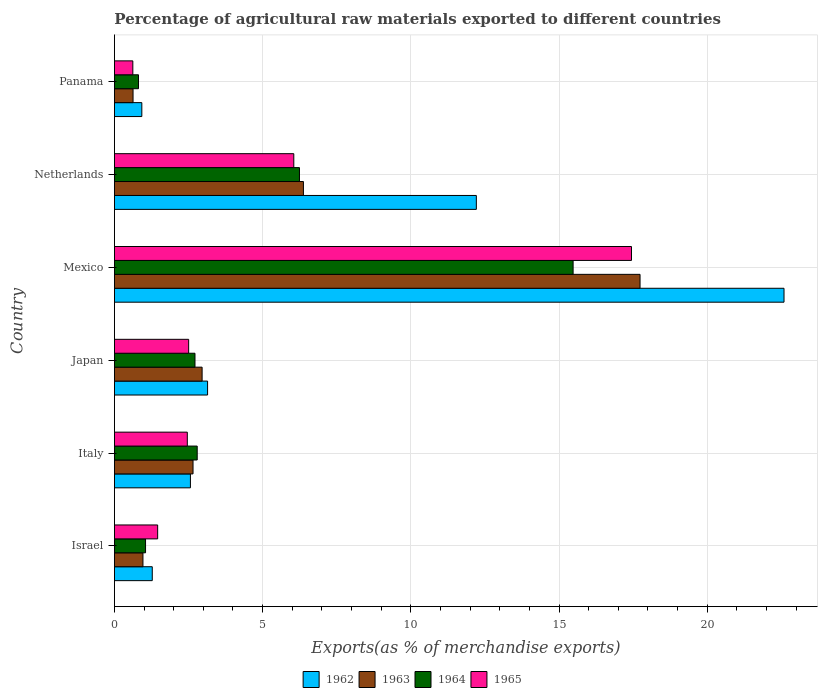How many different coloured bars are there?
Provide a short and direct response. 4. How many groups of bars are there?
Provide a succinct answer. 6. Are the number of bars per tick equal to the number of legend labels?
Keep it short and to the point. Yes. Are the number of bars on each tick of the Y-axis equal?
Provide a succinct answer. Yes. How many bars are there on the 4th tick from the bottom?
Offer a terse response. 4. What is the label of the 3rd group of bars from the top?
Your response must be concise. Mexico. What is the percentage of exports to different countries in 1965 in Israel?
Keep it short and to the point. 1.46. Across all countries, what is the maximum percentage of exports to different countries in 1962?
Provide a short and direct response. 22.59. Across all countries, what is the minimum percentage of exports to different countries in 1962?
Ensure brevity in your answer.  0.92. In which country was the percentage of exports to different countries in 1965 minimum?
Provide a succinct answer. Panama. What is the total percentage of exports to different countries in 1963 in the graph?
Your answer should be compact. 31.31. What is the difference between the percentage of exports to different countries in 1963 in Israel and that in Italy?
Provide a short and direct response. -1.69. What is the difference between the percentage of exports to different countries in 1963 in Israel and the percentage of exports to different countries in 1962 in Panama?
Provide a succinct answer. 0.04. What is the average percentage of exports to different countries in 1963 per country?
Provide a short and direct response. 5.22. What is the difference between the percentage of exports to different countries in 1963 and percentage of exports to different countries in 1965 in Japan?
Give a very brief answer. 0.45. What is the ratio of the percentage of exports to different countries in 1962 in Mexico to that in Netherlands?
Offer a very short reply. 1.85. Is the difference between the percentage of exports to different countries in 1963 in Israel and Panama greater than the difference between the percentage of exports to different countries in 1965 in Israel and Panama?
Ensure brevity in your answer.  No. What is the difference between the highest and the second highest percentage of exports to different countries in 1962?
Your answer should be compact. 10.38. What is the difference between the highest and the lowest percentage of exports to different countries in 1962?
Offer a very short reply. 21.67. In how many countries, is the percentage of exports to different countries in 1964 greater than the average percentage of exports to different countries in 1964 taken over all countries?
Your answer should be compact. 2. Is it the case that in every country, the sum of the percentage of exports to different countries in 1965 and percentage of exports to different countries in 1963 is greater than the sum of percentage of exports to different countries in 1962 and percentage of exports to different countries in 1964?
Provide a short and direct response. No. What does the 3rd bar from the bottom in Panama represents?
Provide a short and direct response. 1964. Is it the case that in every country, the sum of the percentage of exports to different countries in 1962 and percentage of exports to different countries in 1963 is greater than the percentage of exports to different countries in 1964?
Provide a succinct answer. Yes. How many bars are there?
Ensure brevity in your answer.  24. Are the values on the major ticks of X-axis written in scientific E-notation?
Give a very brief answer. No. Does the graph contain grids?
Give a very brief answer. Yes. Where does the legend appear in the graph?
Provide a succinct answer. Bottom center. How are the legend labels stacked?
Offer a terse response. Horizontal. What is the title of the graph?
Offer a terse response. Percentage of agricultural raw materials exported to different countries. Does "1993" appear as one of the legend labels in the graph?
Your answer should be compact. No. What is the label or title of the X-axis?
Provide a succinct answer. Exports(as % of merchandise exports). What is the label or title of the Y-axis?
Make the answer very short. Country. What is the Exports(as % of merchandise exports) in 1962 in Israel?
Keep it short and to the point. 1.28. What is the Exports(as % of merchandise exports) in 1963 in Israel?
Your answer should be very brief. 0.96. What is the Exports(as % of merchandise exports) in 1964 in Israel?
Keep it short and to the point. 1.05. What is the Exports(as % of merchandise exports) of 1965 in Israel?
Keep it short and to the point. 1.46. What is the Exports(as % of merchandise exports) in 1962 in Italy?
Make the answer very short. 2.56. What is the Exports(as % of merchandise exports) in 1963 in Italy?
Your response must be concise. 2.65. What is the Exports(as % of merchandise exports) in 1964 in Italy?
Offer a terse response. 2.79. What is the Exports(as % of merchandise exports) in 1965 in Italy?
Provide a succinct answer. 2.46. What is the Exports(as % of merchandise exports) in 1962 in Japan?
Your answer should be compact. 3.14. What is the Exports(as % of merchandise exports) in 1963 in Japan?
Make the answer very short. 2.96. What is the Exports(as % of merchandise exports) of 1964 in Japan?
Provide a succinct answer. 2.72. What is the Exports(as % of merchandise exports) in 1965 in Japan?
Offer a terse response. 2.5. What is the Exports(as % of merchandise exports) in 1962 in Mexico?
Give a very brief answer. 22.59. What is the Exports(as % of merchandise exports) of 1963 in Mexico?
Your response must be concise. 17.73. What is the Exports(as % of merchandise exports) in 1964 in Mexico?
Provide a short and direct response. 15.48. What is the Exports(as % of merchandise exports) of 1965 in Mexico?
Provide a short and direct response. 17.44. What is the Exports(as % of merchandise exports) of 1962 in Netherlands?
Provide a short and direct response. 12.21. What is the Exports(as % of merchandise exports) of 1963 in Netherlands?
Give a very brief answer. 6.38. What is the Exports(as % of merchandise exports) of 1964 in Netherlands?
Make the answer very short. 6.24. What is the Exports(as % of merchandise exports) of 1965 in Netherlands?
Provide a short and direct response. 6.05. What is the Exports(as % of merchandise exports) of 1962 in Panama?
Your answer should be compact. 0.92. What is the Exports(as % of merchandise exports) of 1963 in Panama?
Make the answer very short. 0.63. What is the Exports(as % of merchandise exports) in 1964 in Panama?
Give a very brief answer. 0.81. What is the Exports(as % of merchandise exports) in 1965 in Panama?
Provide a succinct answer. 0.62. Across all countries, what is the maximum Exports(as % of merchandise exports) of 1962?
Make the answer very short. 22.59. Across all countries, what is the maximum Exports(as % of merchandise exports) of 1963?
Your answer should be very brief. 17.73. Across all countries, what is the maximum Exports(as % of merchandise exports) in 1964?
Provide a short and direct response. 15.48. Across all countries, what is the maximum Exports(as % of merchandise exports) in 1965?
Ensure brevity in your answer.  17.44. Across all countries, what is the minimum Exports(as % of merchandise exports) in 1962?
Offer a terse response. 0.92. Across all countries, what is the minimum Exports(as % of merchandise exports) of 1963?
Offer a very short reply. 0.63. Across all countries, what is the minimum Exports(as % of merchandise exports) in 1964?
Make the answer very short. 0.81. Across all countries, what is the minimum Exports(as % of merchandise exports) of 1965?
Your answer should be very brief. 0.62. What is the total Exports(as % of merchandise exports) in 1962 in the graph?
Give a very brief answer. 42.71. What is the total Exports(as % of merchandise exports) of 1963 in the graph?
Provide a succinct answer. 31.31. What is the total Exports(as % of merchandise exports) in 1964 in the graph?
Offer a very short reply. 29.09. What is the total Exports(as % of merchandise exports) of 1965 in the graph?
Your answer should be compact. 30.54. What is the difference between the Exports(as % of merchandise exports) in 1962 in Israel and that in Italy?
Provide a short and direct response. -1.29. What is the difference between the Exports(as % of merchandise exports) of 1963 in Israel and that in Italy?
Provide a short and direct response. -1.69. What is the difference between the Exports(as % of merchandise exports) in 1964 in Israel and that in Italy?
Provide a succinct answer. -1.74. What is the difference between the Exports(as % of merchandise exports) in 1965 in Israel and that in Italy?
Provide a succinct answer. -1. What is the difference between the Exports(as % of merchandise exports) of 1962 in Israel and that in Japan?
Make the answer very short. -1.87. What is the difference between the Exports(as % of merchandise exports) in 1963 in Israel and that in Japan?
Keep it short and to the point. -2. What is the difference between the Exports(as % of merchandise exports) in 1964 in Israel and that in Japan?
Ensure brevity in your answer.  -1.67. What is the difference between the Exports(as % of merchandise exports) in 1965 in Israel and that in Japan?
Keep it short and to the point. -1.05. What is the difference between the Exports(as % of merchandise exports) of 1962 in Israel and that in Mexico?
Your response must be concise. -21.31. What is the difference between the Exports(as % of merchandise exports) in 1963 in Israel and that in Mexico?
Keep it short and to the point. -16.77. What is the difference between the Exports(as % of merchandise exports) of 1964 in Israel and that in Mexico?
Provide a short and direct response. -14.43. What is the difference between the Exports(as % of merchandise exports) of 1965 in Israel and that in Mexico?
Ensure brevity in your answer.  -15.99. What is the difference between the Exports(as % of merchandise exports) in 1962 in Israel and that in Netherlands?
Offer a very short reply. -10.93. What is the difference between the Exports(as % of merchandise exports) in 1963 in Israel and that in Netherlands?
Your answer should be compact. -5.41. What is the difference between the Exports(as % of merchandise exports) of 1964 in Israel and that in Netherlands?
Provide a succinct answer. -5.19. What is the difference between the Exports(as % of merchandise exports) of 1965 in Israel and that in Netherlands?
Provide a succinct answer. -4.59. What is the difference between the Exports(as % of merchandise exports) of 1962 in Israel and that in Panama?
Your answer should be very brief. 0.35. What is the difference between the Exports(as % of merchandise exports) of 1963 in Israel and that in Panama?
Give a very brief answer. 0.33. What is the difference between the Exports(as % of merchandise exports) in 1964 in Israel and that in Panama?
Offer a terse response. 0.24. What is the difference between the Exports(as % of merchandise exports) of 1965 in Israel and that in Panama?
Your response must be concise. 0.84. What is the difference between the Exports(as % of merchandise exports) in 1962 in Italy and that in Japan?
Your answer should be very brief. -0.58. What is the difference between the Exports(as % of merchandise exports) of 1963 in Italy and that in Japan?
Keep it short and to the point. -0.31. What is the difference between the Exports(as % of merchandise exports) of 1964 in Italy and that in Japan?
Keep it short and to the point. 0.07. What is the difference between the Exports(as % of merchandise exports) in 1965 in Italy and that in Japan?
Provide a succinct answer. -0.05. What is the difference between the Exports(as % of merchandise exports) in 1962 in Italy and that in Mexico?
Give a very brief answer. -20.03. What is the difference between the Exports(as % of merchandise exports) in 1963 in Italy and that in Mexico?
Ensure brevity in your answer.  -15.08. What is the difference between the Exports(as % of merchandise exports) of 1964 in Italy and that in Mexico?
Keep it short and to the point. -12.68. What is the difference between the Exports(as % of merchandise exports) of 1965 in Italy and that in Mexico?
Offer a very short reply. -14.99. What is the difference between the Exports(as % of merchandise exports) in 1962 in Italy and that in Netherlands?
Make the answer very short. -9.65. What is the difference between the Exports(as % of merchandise exports) of 1963 in Italy and that in Netherlands?
Make the answer very short. -3.72. What is the difference between the Exports(as % of merchandise exports) of 1964 in Italy and that in Netherlands?
Provide a succinct answer. -3.45. What is the difference between the Exports(as % of merchandise exports) of 1965 in Italy and that in Netherlands?
Provide a short and direct response. -3.59. What is the difference between the Exports(as % of merchandise exports) in 1962 in Italy and that in Panama?
Give a very brief answer. 1.64. What is the difference between the Exports(as % of merchandise exports) of 1963 in Italy and that in Panama?
Your answer should be very brief. 2.02. What is the difference between the Exports(as % of merchandise exports) in 1964 in Italy and that in Panama?
Give a very brief answer. 1.98. What is the difference between the Exports(as % of merchandise exports) in 1965 in Italy and that in Panama?
Give a very brief answer. 1.84. What is the difference between the Exports(as % of merchandise exports) of 1962 in Japan and that in Mexico?
Your answer should be compact. -19.45. What is the difference between the Exports(as % of merchandise exports) in 1963 in Japan and that in Mexico?
Your response must be concise. -14.78. What is the difference between the Exports(as % of merchandise exports) of 1964 in Japan and that in Mexico?
Offer a very short reply. -12.76. What is the difference between the Exports(as % of merchandise exports) in 1965 in Japan and that in Mexico?
Your response must be concise. -14.94. What is the difference between the Exports(as % of merchandise exports) in 1962 in Japan and that in Netherlands?
Give a very brief answer. -9.07. What is the difference between the Exports(as % of merchandise exports) of 1963 in Japan and that in Netherlands?
Provide a short and direct response. -3.42. What is the difference between the Exports(as % of merchandise exports) in 1964 in Japan and that in Netherlands?
Keep it short and to the point. -3.53. What is the difference between the Exports(as % of merchandise exports) in 1965 in Japan and that in Netherlands?
Provide a succinct answer. -3.55. What is the difference between the Exports(as % of merchandise exports) of 1962 in Japan and that in Panama?
Ensure brevity in your answer.  2.22. What is the difference between the Exports(as % of merchandise exports) in 1963 in Japan and that in Panama?
Provide a succinct answer. 2.33. What is the difference between the Exports(as % of merchandise exports) in 1964 in Japan and that in Panama?
Offer a terse response. 1.91. What is the difference between the Exports(as % of merchandise exports) in 1965 in Japan and that in Panama?
Offer a very short reply. 1.88. What is the difference between the Exports(as % of merchandise exports) of 1962 in Mexico and that in Netherlands?
Make the answer very short. 10.38. What is the difference between the Exports(as % of merchandise exports) of 1963 in Mexico and that in Netherlands?
Your answer should be very brief. 11.36. What is the difference between the Exports(as % of merchandise exports) in 1964 in Mexico and that in Netherlands?
Your answer should be compact. 9.23. What is the difference between the Exports(as % of merchandise exports) in 1965 in Mexico and that in Netherlands?
Keep it short and to the point. 11.39. What is the difference between the Exports(as % of merchandise exports) in 1962 in Mexico and that in Panama?
Your answer should be compact. 21.67. What is the difference between the Exports(as % of merchandise exports) in 1963 in Mexico and that in Panama?
Keep it short and to the point. 17.11. What is the difference between the Exports(as % of merchandise exports) in 1964 in Mexico and that in Panama?
Provide a short and direct response. 14.66. What is the difference between the Exports(as % of merchandise exports) in 1965 in Mexico and that in Panama?
Your answer should be compact. 16.82. What is the difference between the Exports(as % of merchandise exports) in 1962 in Netherlands and that in Panama?
Your answer should be very brief. 11.29. What is the difference between the Exports(as % of merchandise exports) in 1963 in Netherlands and that in Panama?
Offer a very short reply. 5.75. What is the difference between the Exports(as % of merchandise exports) of 1964 in Netherlands and that in Panama?
Keep it short and to the point. 5.43. What is the difference between the Exports(as % of merchandise exports) in 1965 in Netherlands and that in Panama?
Your response must be concise. 5.43. What is the difference between the Exports(as % of merchandise exports) of 1962 in Israel and the Exports(as % of merchandise exports) of 1963 in Italy?
Your answer should be very brief. -1.38. What is the difference between the Exports(as % of merchandise exports) of 1962 in Israel and the Exports(as % of merchandise exports) of 1964 in Italy?
Offer a very short reply. -1.52. What is the difference between the Exports(as % of merchandise exports) of 1962 in Israel and the Exports(as % of merchandise exports) of 1965 in Italy?
Ensure brevity in your answer.  -1.18. What is the difference between the Exports(as % of merchandise exports) in 1963 in Israel and the Exports(as % of merchandise exports) in 1964 in Italy?
Offer a very short reply. -1.83. What is the difference between the Exports(as % of merchandise exports) in 1963 in Israel and the Exports(as % of merchandise exports) in 1965 in Italy?
Offer a terse response. -1.5. What is the difference between the Exports(as % of merchandise exports) of 1964 in Israel and the Exports(as % of merchandise exports) of 1965 in Italy?
Offer a very short reply. -1.41. What is the difference between the Exports(as % of merchandise exports) of 1962 in Israel and the Exports(as % of merchandise exports) of 1963 in Japan?
Your answer should be compact. -1.68. What is the difference between the Exports(as % of merchandise exports) in 1962 in Israel and the Exports(as % of merchandise exports) in 1964 in Japan?
Offer a terse response. -1.44. What is the difference between the Exports(as % of merchandise exports) of 1962 in Israel and the Exports(as % of merchandise exports) of 1965 in Japan?
Make the answer very short. -1.23. What is the difference between the Exports(as % of merchandise exports) of 1963 in Israel and the Exports(as % of merchandise exports) of 1964 in Japan?
Your answer should be very brief. -1.76. What is the difference between the Exports(as % of merchandise exports) of 1963 in Israel and the Exports(as % of merchandise exports) of 1965 in Japan?
Make the answer very short. -1.54. What is the difference between the Exports(as % of merchandise exports) in 1964 in Israel and the Exports(as % of merchandise exports) in 1965 in Japan?
Offer a terse response. -1.45. What is the difference between the Exports(as % of merchandise exports) of 1962 in Israel and the Exports(as % of merchandise exports) of 1963 in Mexico?
Your response must be concise. -16.46. What is the difference between the Exports(as % of merchandise exports) of 1962 in Israel and the Exports(as % of merchandise exports) of 1964 in Mexico?
Keep it short and to the point. -14.2. What is the difference between the Exports(as % of merchandise exports) of 1962 in Israel and the Exports(as % of merchandise exports) of 1965 in Mexico?
Your response must be concise. -16.17. What is the difference between the Exports(as % of merchandise exports) of 1963 in Israel and the Exports(as % of merchandise exports) of 1964 in Mexico?
Ensure brevity in your answer.  -14.51. What is the difference between the Exports(as % of merchandise exports) in 1963 in Israel and the Exports(as % of merchandise exports) in 1965 in Mexico?
Your response must be concise. -16.48. What is the difference between the Exports(as % of merchandise exports) of 1964 in Israel and the Exports(as % of merchandise exports) of 1965 in Mexico?
Your response must be concise. -16.39. What is the difference between the Exports(as % of merchandise exports) of 1962 in Israel and the Exports(as % of merchandise exports) of 1963 in Netherlands?
Your answer should be very brief. -5.1. What is the difference between the Exports(as % of merchandise exports) of 1962 in Israel and the Exports(as % of merchandise exports) of 1964 in Netherlands?
Make the answer very short. -4.97. What is the difference between the Exports(as % of merchandise exports) in 1962 in Israel and the Exports(as % of merchandise exports) in 1965 in Netherlands?
Keep it short and to the point. -4.77. What is the difference between the Exports(as % of merchandise exports) of 1963 in Israel and the Exports(as % of merchandise exports) of 1964 in Netherlands?
Provide a succinct answer. -5.28. What is the difference between the Exports(as % of merchandise exports) in 1963 in Israel and the Exports(as % of merchandise exports) in 1965 in Netherlands?
Offer a terse response. -5.09. What is the difference between the Exports(as % of merchandise exports) in 1964 in Israel and the Exports(as % of merchandise exports) in 1965 in Netherlands?
Provide a short and direct response. -5. What is the difference between the Exports(as % of merchandise exports) of 1962 in Israel and the Exports(as % of merchandise exports) of 1963 in Panama?
Make the answer very short. 0.65. What is the difference between the Exports(as % of merchandise exports) of 1962 in Israel and the Exports(as % of merchandise exports) of 1964 in Panama?
Your response must be concise. 0.46. What is the difference between the Exports(as % of merchandise exports) in 1962 in Israel and the Exports(as % of merchandise exports) in 1965 in Panama?
Your answer should be very brief. 0.66. What is the difference between the Exports(as % of merchandise exports) in 1963 in Israel and the Exports(as % of merchandise exports) in 1964 in Panama?
Your response must be concise. 0.15. What is the difference between the Exports(as % of merchandise exports) in 1963 in Israel and the Exports(as % of merchandise exports) in 1965 in Panama?
Ensure brevity in your answer.  0.34. What is the difference between the Exports(as % of merchandise exports) in 1964 in Israel and the Exports(as % of merchandise exports) in 1965 in Panama?
Provide a short and direct response. 0.43. What is the difference between the Exports(as % of merchandise exports) in 1962 in Italy and the Exports(as % of merchandise exports) in 1963 in Japan?
Make the answer very short. -0.39. What is the difference between the Exports(as % of merchandise exports) in 1962 in Italy and the Exports(as % of merchandise exports) in 1964 in Japan?
Give a very brief answer. -0.15. What is the difference between the Exports(as % of merchandise exports) of 1962 in Italy and the Exports(as % of merchandise exports) of 1965 in Japan?
Your answer should be very brief. 0.06. What is the difference between the Exports(as % of merchandise exports) in 1963 in Italy and the Exports(as % of merchandise exports) in 1964 in Japan?
Ensure brevity in your answer.  -0.07. What is the difference between the Exports(as % of merchandise exports) of 1963 in Italy and the Exports(as % of merchandise exports) of 1965 in Japan?
Offer a terse response. 0.15. What is the difference between the Exports(as % of merchandise exports) of 1964 in Italy and the Exports(as % of merchandise exports) of 1965 in Japan?
Make the answer very short. 0.29. What is the difference between the Exports(as % of merchandise exports) of 1962 in Italy and the Exports(as % of merchandise exports) of 1963 in Mexico?
Provide a succinct answer. -15.17. What is the difference between the Exports(as % of merchandise exports) in 1962 in Italy and the Exports(as % of merchandise exports) in 1964 in Mexico?
Make the answer very short. -12.91. What is the difference between the Exports(as % of merchandise exports) in 1962 in Italy and the Exports(as % of merchandise exports) in 1965 in Mexico?
Provide a succinct answer. -14.88. What is the difference between the Exports(as % of merchandise exports) in 1963 in Italy and the Exports(as % of merchandise exports) in 1964 in Mexico?
Offer a terse response. -12.82. What is the difference between the Exports(as % of merchandise exports) in 1963 in Italy and the Exports(as % of merchandise exports) in 1965 in Mexico?
Offer a very short reply. -14.79. What is the difference between the Exports(as % of merchandise exports) in 1964 in Italy and the Exports(as % of merchandise exports) in 1965 in Mexico?
Keep it short and to the point. -14.65. What is the difference between the Exports(as % of merchandise exports) in 1962 in Italy and the Exports(as % of merchandise exports) in 1963 in Netherlands?
Your answer should be compact. -3.81. What is the difference between the Exports(as % of merchandise exports) in 1962 in Italy and the Exports(as % of merchandise exports) in 1964 in Netherlands?
Offer a very short reply. -3.68. What is the difference between the Exports(as % of merchandise exports) of 1962 in Italy and the Exports(as % of merchandise exports) of 1965 in Netherlands?
Your answer should be compact. -3.49. What is the difference between the Exports(as % of merchandise exports) of 1963 in Italy and the Exports(as % of merchandise exports) of 1964 in Netherlands?
Make the answer very short. -3.59. What is the difference between the Exports(as % of merchandise exports) in 1963 in Italy and the Exports(as % of merchandise exports) in 1965 in Netherlands?
Offer a very short reply. -3.4. What is the difference between the Exports(as % of merchandise exports) in 1964 in Italy and the Exports(as % of merchandise exports) in 1965 in Netherlands?
Your response must be concise. -3.26. What is the difference between the Exports(as % of merchandise exports) of 1962 in Italy and the Exports(as % of merchandise exports) of 1963 in Panama?
Provide a succinct answer. 1.94. What is the difference between the Exports(as % of merchandise exports) in 1962 in Italy and the Exports(as % of merchandise exports) in 1964 in Panama?
Ensure brevity in your answer.  1.75. What is the difference between the Exports(as % of merchandise exports) in 1962 in Italy and the Exports(as % of merchandise exports) in 1965 in Panama?
Give a very brief answer. 1.94. What is the difference between the Exports(as % of merchandise exports) of 1963 in Italy and the Exports(as % of merchandise exports) of 1964 in Panama?
Your answer should be very brief. 1.84. What is the difference between the Exports(as % of merchandise exports) in 1963 in Italy and the Exports(as % of merchandise exports) in 1965 in Panama?
Your response must be concise. 2.03. What is the difference between the Exports(as % of merchandise exports) in 1964 in Italy and the Exports(as % of merchandise exports) in 1965 in Panama?
Your answer should be compact. 2.17. What is the difference between the Exports(as % of merchandise exports) of 1962 in Japan and the Exports(as % of merchandise exports) of 1963 in Mexico?
Keep it short and to the point. -14.59. What is the difference between the Exports(as % of merchandise exports) of 1962 in Japan and the Exports(as % of merchandise exports) of 1964 in Mexico?
Your response must be concise. -12.33. What is the difference between the Exports(as % of merchandise exports) of 1962 in Japan and the Exports(as % of merchandise exports) of 1965 in Mexico?
Provide a succinct answer. -14.3. What is the difference between the Exports(as % of merchandise exports) in 1963 in Japan and the Exports(as % of merchandise exports) in 1964 in Mexico?
Ensure brevity in your answer.  -12.52. What is the difference between the Exports(as % of merchandise exports) of 1963 in Japan and the Exports(as % of merchandise exports) of 1965 in Mexico?
Offer a very short reply. -14.49. What is the difference between the Exports(as % of merchandise exports) of 1964 in Japan and the Exports(as % of merchandise exports) of 1965 in Mexico?
Keep it short and to the point. -14.73. What is the difference between the Exports(as % of merchandise exports) in 1962 in Japan and the Exports(as % of merchandise exports) in 1963 in Netherlands?
Your answer should be very brief. -3.23. What is the difference between the Exports(as % of merchandise exports) of 1962 in Japan and the Exports(as % of merchandise exports) of 1964 in Netherlands?
Ensure brevity in your answer.  -3.1. What is the difference between the Exports(as % of merchandise exports) in 1962 in Japan and the Exports(as % of merchandise exports) in 1965 in Netherlands?
Provide a succinct answer. -2.91. What is the difference between the Exports(as % of merchandise exports) of 1963 in Japan and the Exports(as % of merchandise exports) of 1964 in Netherlands?
Ensure brevity in your answer.  -3.28. What is the difference between the Exports(as % of merchandise exports) of 1963 in Japan and the Exports(as % of merchandise exports) of 1965 in Netherlands?
Offer a very short reply. -3.09. What is the difference between the Exports(as % of merchandise exports) of 1964 in Japan and the Exports(as % of merchandise exports) of 1965 in Netherlands?
Keep it short and to the point. -3.33. What is the difference between the Exports(as % of merchandise exports) of 1962 in Japan and the Exports(as % of merchandise exports) of 1963 in Panama?
Your answer should be very brief. 2.51. What is the difference between the Exports(as % of merchandise exports) in 1962 in Japan and the Exports(as % of merchandise exports) in 1964 in Panama?
Keep it short and to the point. 2.33. What is the difference between the Exports(as % of merchandise exports) in 1962 in Japan and the Exports(as % of merchandise exports) in 1965 in Panama?
Keep it short and to the point. 2.52. What is the difference between the Exports(as % of merchandise exports) of 1963 in Japan and the Exports(as % of merchandise exports) of 1964 in Panama?
Offer a very short reply. 2.15. What is the difference between the Exports(as % of merchandise exports) of 1963 in Japan and the Exports(as % of merchandise exports) of 1965 in Panama?
Make the answer very short. 2.34. What is the difference between the Exports(as % of merchandise exports) of 1964 in Japan and the Exports(as % of merchandise exports) of 1965 in Panama?
Make the answer very short. 2.1. What is the difference between the Exports(as % of merchandise exports) of 1962 in Mexico and the Exports(as % of merchandise exports) of 1963 in Netherlands?
Your answer should be very brief. 16.21. What is the difference between the Exports(as % of merchandise exports) of 1962 in Mexico and the Exports(as % of merchandise exports) of 1964 in Netherlands?
Provide a succinct answer. 16.35. What is the difference between the Exports(as % of merchandise exports) in 1962 in Mexico and the Exports(as % of merchandise exports) in 1965 in Netherlands?
Make the answer very short. 16.54. What is the difference between the Exports(as % of merchandise exports) in 1963 in Mexico and the Exports(as % of merchandise exports) in 1964 in Netherlands?
Give a very brief answer. 11.49. What is the difference between the Exports(as % of merchandise exports) of 1963 in Mexico and the Exports(as % of merchandise exports) of 1965 in Netherlands?
Provide a short and direct response. 11.68. What is the difference between the Exports(as % of merchandise exports) of 1964 in Mexico and the Exports(as % of merchandise exports) of 1965 in Netherlands?
Keep it short and to the point. 9.42. What is the difference between the Exports(as % of merchandise exports) of 1962 in Mexico and the Exports(as % of merchandise exports) of 1963 in Panama?
Provide a succinct answer. 21.96. What is the difference between the Exports(as % of merchandise exports) in 1962 in Mexico and the Exports(as % of merchandise exports) in 1964 in Panama?
Make the answer very short. 21.78. What is the difference between the Exports(as % of merchandise exports) in 1962 in Mexico and the Exports(as % of merchandise exports) in 1965 in Panama?
Your answer should be compact. 21.97. What is the difference between the Exports(as % of merchandise exports) in 1963 in Mexico and the Exports(as % of merchandise exports) in 1964 in Panama?
Offer a terse response. 16.92. What is the difference between the Exports(as % of merchandise exports) in 1963 in Mexico and the Exports(as % of merchandise exports) in 1965 in Panama?
Provide a short and direct response. 17.11. What is the difference between the Exports(as % of merchandise exports) in 1964 in Mexico and the Exports(as % of merchandise exports) in 1965 in Panama?
Your answer should be very brief. 14.85. What is the difference between the Exports(as % of merchandise exports) in 1962 in Netherlands and the Exports(as % of merchandise exports) in 1963 in Panama?
Your answer should be very brief. 11.58. What is the difference between the Exports(as % of merchandise exports) in 1962 in Netherlands and the Exports(as % of merchandise exports) in 1964 in Panama?
Keep it short and to the point. 11.4. What is the difference between the Exports(as % of merchandise exports) of 1962 in Netherlands and the Exports(as % of merchandise exports) of 1965 in Panama?
Your answer should be very brief. 11.59. What is the difference between the Exports(as % of merchandise exports) in 1963 in Netherlands and the Exports(as % of merchandise exports) in 1964 in Panama?
Make the answer very short. 5.56. What is the difference between the Exports(as % of merchandise exports) of 1963 in Netherlands and the Exports(as % of merchandise exports) of 1965 in Panama?
Offer a very short reply. 5.76. What is the difference between the Exports(as % of merchandise exports) in 1964 in Netherlands and the Exports(as % of merchandise exports) in 1965 in Panama?
Provide a short and direct response. 5.62. What is the average Exports(as % of merchandise exports) in 1962 per country?
Provide a short and direct response. 7.12. What is the average Exports(as % of merchandise exports) of 1963 per country?
Ensure brevity in your answer.  5.22. What is the average Exports(as % of merchandise exports) of 1964 per country?
Your response must be concise. 4.85. What is the average Exports(as % of merchandise exports) of 1965 per country?
Offer a very short reply. 5.09. What is the difference between the Exports(as % of merchandise exports) in 1962 and Exports(as % of merchandise exports) in 1963 in Israel?
Your answer should be compact. 0.31. What is the difference between the Exports(as % of merchandise exports) of 1962 and Exports(as % of merchandise exports) of 1964 in Israel?
Provide a short and direct response. 0.23. What is the difference between the Exports(as % of merchandise exports) of 1962 and Exports(as % of merchandise exports) of 1965 in Israel?
Your response must be concise. -0.18. What is the difference between the Exports(as % of merchandise exports) in 1963 and Exports(as % of merchandise exports) in 1964 in Israel?
Offer a very short reply. -0.09. What is the difference between the Exports(as % of merchandise exports) in 1963 and Exports(as % of merchandise exports) in 1965 in Israel?
Make the answer very short. -0.5. What is the difference between the Exports(as % of merchandise exports) of 1964 and Exports(as % of merchandise exports) of 1965 in Israel?
Keep it short and to the point. -0.41. What is the difference between the Exports(as % of merchandise exports) of 1962 and Exports(as % of merchandise exports) of 1963 in Italy?
Offer a terse response. -0.09. What is the difference between the Exports(as % of merchandise exports) of 1962 and Exports(as % of merchandise exports) of 1964 in Italy?
Your answer should be very brief. -0.23. What is the difference between the Exports(as % of merchandise exports) in 1962 and Exports(as % of merchandise exports) in 1965 in Italy?
Give a very brief answer. 0.1. What is the difference between the Exports(as % of merchandise exports) in 1963 and Exports(as % of merchandise exports) in 1964 in Italy?
Offer a terse response. -0.14. What is the difference between the Exports(as % of merchandise exports) in 1963 and Exports(as % of merchandise exports) in 1965 in Italy?
Your response must be concise. 0.19. What is the difference between the Exports(as % of merchandise exports) in 1964 and Exports(as % of merchandise exports) in 1965 in Italy?
Provide a succinct answer. 0.33. What is the difference between the Exports(as % of merchandise exports) of 1962 and Exports(as % of merchandise exports) of 1963 in Japan?
Provide a short and direct response. 0.18. What is the difference between the Exports(as % of merchandise exports) of 1962 and Exports(as % of merchandise exports) of 1964 in Japan?
Give a very brief answer. 0.42. What is the difference between the Exports(as % of merchandise exports) in 1962 and Exports(as % of merchandise exports) in 1965 in Japan?
Provide a succinct answer. 0.64. What is the difference between the Exports(as % of merchandise exports) of 1963 and Exports(as % of merchandise exports) of 1964 in Japan?
Ensure brevity in your answer.  0.24. What is the difference between the Exports(as % of merchandise exports) in 1963 and Exports(as % of merchandise exports) in 1965 in Japan?
Provide a short and direct response. 0.45. What is the difference between the Exports(as % of merchandise exports) of 1964 and Exports(as % of merchandise exports) of 1965 in Japan?
Provide a short and direct response. 0.21. What is the difference between the Exports(as % of merchandise exports) of 1962 and Exports(as % of merchandise exports) of 1963 in Mexico?
Ensure brevity in your answer.  4.86. What is the difference between the Exports(as % of merchandise exports) of 1962 and Exports(as % of merchandise exports) of 1964 in Mexico?
Offer a terse response. 7.12. What is the difference between the Exports(as % of merchandise exports) in 1962 and Exports(as % of merchandise exports) in 1965 in Mexico?
Your answer should be very brief. 5.15. What is the difference between the Exports(as % of merchandise exports) of 1963 and Exports(as % of merchandise exports) of 1964 in Mexico?
Provide a succinct answer. 2.26. What is the difference between the Exports(as % of merchandise exports) of 1963 and Exports(as % of merchandise exports) of 1965 in Mexico?
Provide a short and direct response. 0.29. What is the difference between the Exports(as % of merchandise exports) in 1964 and Exports(as % of merchandise exports) in 1965 in Mexico?
Provide a short and direct response. -1.97. What is the difference between the Exports(as % of merchandise exports) of 1962 and Exports(as % of merchandise exports) of 1963 in Netherlands?
Make the answer very short. 5.83. What is the difference between the Exports(as % of merchandise exports) in 1962 and Exports(as % of merchandise exports) in 1964 in Netherlands?
Your answer should be compact. 5.97. What is the difference between the Exports(as % of merchandise exports) in 1962 and Exports(as % of merchandise exports) in 1965 in Netherlands?
Give a very brief answer. 6.16. What is the difference between the Exports(as % of merchandise exports) in 1963 and Exports(as % of merchandise exports) in 1964 in Netherlands?
Ensure brevity in your answer.  0.13. What is the difference between the Exports(as % of merchandise exports) of 1963 and Exports(as % of merchandise exports) of 1965 in Netherlands?
Your answer should be very brief. 0.32. What is the difference between the Exports(as % of merchandise exports) of 1964 and Exports(as % of merchandise exports) of 1965 in Netherlands?
Ensure brevity in your answer.  0.19. What is the difference between the Exports(as % of merchandise exports) of 1962 and Exports(as % of merchandise exports) of 1963 in Panama?
Your answer should be compact. 0.3. What is the difference between the Exports(as % of merchandise exports) of 1962 and Exports(as % of merchandise exports) of 1964 in Panama?
Provide a short and direct response. 0.11. What is the difference between the Exports(as % of merchandise exports) in 1962 and Exports(as % of merchandise exports) in 1965 in Panama?
Your answer should be very brief. 0.3. What is the difference between the Exports(as % of merchandise exports) of 1963 and Exports(as % of merchandise exports) of 1964 in Panama?
Your answer should be compact. -0.18. What is the difference between the Exports(as % of merchandise exports) of 1963 and Exports(as % of merchandise exports) of 1965 in Panama?
Ensure brevity in your answer.  0.01. What is the difference between the Exports(as % of merchandise exports) of 1964 and Exports(as % of merchandise exports) of 1965 in Panama?
Your answer should be very brief. 0.19. What is the ratio of the Exports(as % of merchandise exports) in 1962 in Israel to that in Italy?
Make the answer very short. 0.5. What is the ratio of the Exports(as % of merchandise exports) in 1963 in Israel to that in Italy?
Give a very brief answer. 0.36. What is the ratio of the Exports(as % of merchandise exports) of 1964 in Israel to that in Italy?
Ensure brevity in your answer.  0.38. What is the ratio of the Exports(as % of merchandise exports) of 1965 in Israel to that in Italy?
Make the answer very short. 0.59. What is the ratio of the Exports(as % of merchandise exports) in 1962 in Israel to that in Japan?
Your answer should be compact. 0.41. What is the ratio of the Exports(as % of merchandise exports) of 1963 in Israel to that in Japan?
Make the answer very short. 0.33. What is the ratio of the Exports(as % of merchandise exports) of 1964 in Israel to that in Japan?
Provide a succinct answer. 0.39. What is the ratio of the Exports(as % of merchandise exports) of 1965 in Israel to that in Japan?
Give a very brief answer. 0.58. What is the ratio of the Exports(as % of merchandise exports) of 1962 in Israel to that in Mexico?
Your response must be concise. 0.06. What is the ratio of the Exports(as % of merchandise exports) in 1963 in Israel to that in Mexico?
Your answer should be very brief. 0.05. What is the ratio of the Exports(as % of merchandise exports) in 1964 in Israel to that in Mexico?
Keep it short and to the point. 0.07. What is the ratio of the Exports(as % of merchandise exports) of 1965 in Israel to that in Mexico?
Provide a short and direct response. 0.08. What is the ratio of the Exports(as % of merchandise exports) of 1962 in Israel to that in Netherlands?
Provide a short and direct response. 0.1. What is the ratio of the Exports(as % of merchandise exports) in 1963 in Israel to that in Netherlands?
Your answer should be very brief. 0.15. What is the ratio of the Exports(as % of merchandise exports) in 1964 in Israel to that in Netherlands?
Offer a terse response. 0.17. What is the ratio of the Exports(as % of merchandise exports) in 1965 in Israel to that in Netherlands?
Your answer should be very brief. 0.24. What is the ratio of the Exports(as % of merchandise exports) in 1962 in Israel to that in Panama?
Your answer should be very brief. 1.38. What is the ratio of the Exports(as % of merchandise exports) of 1963 in Israel to that in Panama?
Keep it short and to the point. 1.53. What is the ratio of the Exports(as % of merchandise exports) in 1964 in Israel to that in Panama?
Ensure brevity in your answer.  1.29. What is the ratio of the Exports(as % of merchandise exports) in 1965 in Israel to that in Panama?
Keep it short and to the point. 2.35. What is the ratio of the Exports(as % of merchandise exports) in 1962 in Italy to that in Japan?
Your response must be concise. 0.82. What is the ratio of the Exports(as % of merchandise exports) of 1963 in Italy to that in Japan?
Your response must be concise. 0.9. What is the ratio of the Exports(as % of merchandise exports) of 1964 in Italy to that in Japan?
Make the answer very short. 1.03. What is the ratio of the Exports(as % of merchandise exports) in 1965 in Italy to that in Japan?
Offer a very short reply. 0.98. What is the ratio of the Exports(as % of merchandise exports) in 1962 in Italy to that in Mexico?
Your answer should be compact. 0.11. What is the ratio of the Exports(as % of merchandise exports) in 1963 in Italy to that in Mexico?
Provide a succinct answer. 0.15. What is the ratio of the Exports(as % of merchandise exports) of 1964 in Italy to that in Mexico?
Provide a short and direct response. 0.18. What is the ratio of the Exports(as % of merchandise exports) in 1965 in Italy to that in Mexico?
Offer a very short reply. 0.14. What is the ratio of the Exports(as % of merchandise exports) in 1962 in Italy to that in Netherlands?
Give a very brief answer. 0.21. What is the ratio of the Exports(as % of merchandise exports) of 1963 in Italy to that in Netherlands?
Provide a succinct answer. 0.42. What is the ratio of the Exports(as % of merchandise exports) of 1964 in Italy to that in Netherlands?
Your response must be concise. 0.45. What is the ratio of the Exports(as % of merchandise exports) in 1965 in Italy to that in Netherlands?
Ensure brevity in your answer.  0.41. What is the ratio of the Exports(as % of merchandise exports) of 1962 in Italy to that in Panama?
Ensure brevity in your answer.  2.77. What is the ratio of the Exports(as % of merchandise exports) of 1963 in Italy to that in Panama?
Make the answer very short. 4.22. What is the ratio of the Exports(as % of merchandise exports) in 1964 in Italy to that in Panama?
Your answer should be compact. 3.44. What is the ratio of the Exports(as % of merchandise exports) of 1965 in Italy to that in Panama?
Give a very brief answer. 3.96. What is the ratio of the Exports(as % of merchandise exports) of 1962 in Japan to that in Mexico?
Your answer should be very brief. 0.14. What is the ratio of the Exports(as % of merchandise exports) in 1963 in Japan to that in Mexico?
Your answer should be very brief. 0.17. What is the ratio of the Exports(as % of merchandise exports) in 1964 in Japan to that in Mexico?
Offer a terse response. 0.18. What is the ratio of the Exports(as % of merchandise exports) in 1965 in Japan to that in Mexico?
Your answer should be compact. 0.14. What is the ratio of the Exports(as % of merchandise exports) in 1962 in Japan to that in Netherlands?
Provide a short and direct response. 0.26. What is the ratio of the Exports(as % of merchandise exports) in 1963 in Japan to that in Netherlands?
Keep it short and to the point. 0.46. What is the ratio of the Exports(as % of merchandise exports) in 1964 in Japan to that in Netherlands?
Offer a terse response. 0.44. What is the ratio of the Exports(as % of merchandise exports) of 1965 in Japan to that in Netherlands?
Your response must be concise. 0.41. What is the ratio of the Exports(as % of merchandise exports) in 1962 in Japan to that in Panama?
Ensure brevity in your answer.  3.4. What is the ratio of the Exports(as % of merchandise exports) of 1963 in Japan to that in Panama?
Your answer should be compact. 4.71. What is the ratio of the Exports(as % of merchandise exports) in 1964 in Japan to that in Panama?
Provide a succinct answer. 3.35. What is the ratio of the Exports(as % of merchandise exports) of 1965 in Japan to that in Panama?
Your answer should be compact. 4.04. What is the ratio of the Exports(as % of merchandise exports) in 1962 in Mexico to that in Netherlands?
Give a very brief answer. 1.85. What is the ratio of the Exports(as % of merchandise exports) of 1963 in Mexico to that in Netherlands?
Give a very brief answer. 2.78. What is the ratio of the Exports(as % of merchandise exports) in 1964 in Mexico to that in Netherlands?
Offer a very short reply. 2.48. What is the ratio of the Exports(as % of merchandise exports) in 1965 in Mexico to that in Netherlands?
Ensure brevity in your answer.  2.88. What is the ratio of the Exports(as % of merchandise exports) in 1962 in Mexico to that in Panama?
Make the answer very short. 24.43. What is the ratio of the Exports(as % of merchandise exports) of 1963 in Mexico to that in Panama?
Your answer should be compact. 28.23. What is the ratio of the Exports(as % of merchandise exports) in 1964 in Mexico to that in Panama?
Offer a terse response. 19.05. What is the ratio of the Exports(as % of merchandise exports) in 1965 in Mexico to that in Panama?
Keep it short and to the point. 28.11. What is the ratio of the Exports(as % of merchandise exports) in 1962 in Netherlands to that in Panama?
Offer a terse response. 13.21. What is the ratio of the Exports(as % of merchandise exports) in 1963 in Netherlands to that in Panama?
Your response must be concise. 10.15. What is the ratio of the Exports(as % of merchandise exports) of 1964 in Netherlands to that in Panama?
Give a very brief answer. 7.69. What is the ratio of the Exports(as % of merchandise exports) of 1965 in Netherlands to that in Panama?
Ensure brevity in your answer.  9.75. What is the difference between the highest and the second highest Exports(as % of merchandise exports) in 1962?
Provide a short and direct response. 10.38. What is the difference between the highest and the second highest Exports(as % of merchandise exports) in 1963?
Your answer should be compact. 11.36. What is the difference between the highest and the second highest Exports(as % of merchandise exports) of 1964?
Your answer should be very brief. 9.23. What is the difference between the highest and the second highest Exports(as % of merchandise exports) of 1965?
Offer a terse response. 11.39. What is the difference between the highest and the lowest Exports(as % of merchandise exports) of 1962?
Provide a short and direct response. 21.67. What is the difference between the highest and the lowest Exports(as % of merchandise exports) in 1963?
Provide a succinct answer. 17.11. What is the difference between the highest and the lowest Exports(as % of merchandise exports) of 1964?
Offer a terse response. 14.66. What is the difference between the highest and the lowest Exports(as % of merchandise exports) in 1965?
Your answer should be compact. 16.82. 